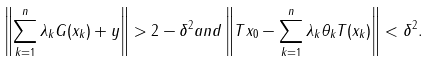Convert formula to latex. <formula><loc_0><loc_0><loc_500><loc_500>\left \| \sum _ { k = 1 } ^ { n } { \lambda _ { k } G ( x _ { k } ) } + y \right \| > 2 - \delta ^ { 2 } a n d \left \| T x _ { 0 } - \sum _ { k = 1 } ^ { n } { \lambda _ { k } \theta _ { k } T ( x _ { k } ) } \right \| < \delta ^ { 2 } .</formula> 